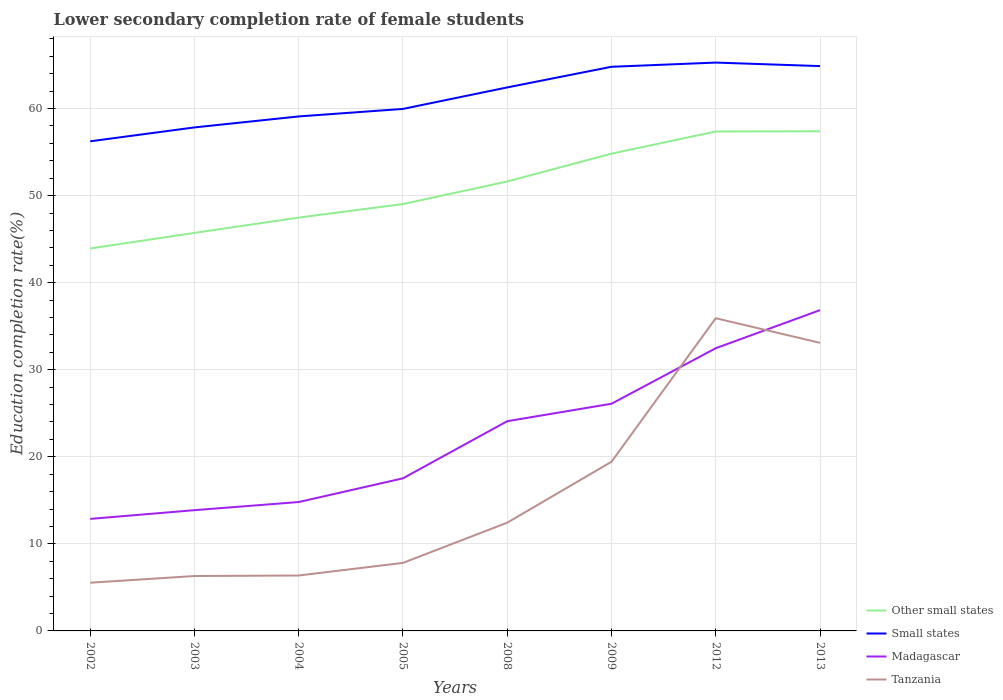Is the number of lines equal to the number of legend labels?
Offer a very short reply. Yes. Across all years, what is the maximum lower secondary completion rate of female students in Madagascar?
Your answer should be compact. 12.87. In which year was the lower secondary completion rate of female students in Madagascar maximum?
Your answer should be compact. 2002. What is the total lower secondary completion rate of female students in Other small states in the graph?
Your response must be concise. -5.9. What is the difference between the highest and the second highest lower secondary completion rate of female students in Madagascar?
Offer a very short reply. 23.98. Does the graph contain grids?
Offer a terse response. Yes. Where does the legend appear in the graph?
Make the answer very short. Bottom right. How many legend labels are there?
Offer a very short reply. 4. What is the title of the graph?
Provide a succinct answer. Lower secondary completion rate of female students. Does "Spain" appear as one of the legend labels in the graph?
Keep it short and to the point. No. What is the label or title of the Y-axis?
Your response must be concise. Education completion rate(%). What is the Education completion rate(%) of Other small states in 2002?
Make the answer very short. 43.92. What is the Education completion rate(%) of Small states in 2002?
Provide a short and direct response. 56.24. What is the Education completion rate(%) of Madagascar in 2002?
Make the answer very short. 12.87. What is the Education completion rate(%) in Tanzania in 2002?
Offer a terse response. 5.54. What is the Education completion rate(%) of Other small states in 2003?
Keep it short and to the point. 45.72. What is the Education completion rate(%) of Small states in 2003?
Your response must be concise. 57.83. What is the Education completion rate(%) in Madagascar in 2003?
Your answer should be very brief. 13.87. What is the Education completion rate(%) of Tanzania in 2003?
Give a very brief answer. 6.31. What is the Education completion rate(%) of Other small states in 2004?
Keep it short and to the point. 47.47. What is the Education completion rate(%) of Small states in 2004?
Keep it short and to the point. 59.09. What is the Education completion rate(%) in Madagascar in 2004?
Your answer should be compact. 14.8. What is the Education completion rate(%) in Tanzania in 2004?
Keep it short and to the point. 6.37. What is the Education completion rate(%) in Other small states in 2005?
Provide a short and direct response. 49.03. What is the Education completion rate(%) of Small states in 2005?
Offer a very short reply. 59.96. What is the Education completion rate(%) in Madagascar in 2005?
Provide a short and direct response. 17.53. What is the Education completion rate(%) in Tanzania in 2005?
Offer a terse response. 7.81. What is the Education completion rate(%) in Other small states in 2008?
Ensure brevity in your answer.  51.62. What is the Education completion rate(%) of Small states in 2008?
Your answer should be very brief. 62.43. What is the Education completion rate(%) in Madagascar in 2008?
Your answer should be compact. 24.09. What is the Education completion rate(%) of Tanzania in 2008?
Give a very brief answer. 12.43. What is the Education completion rate(%) of Other small states in 2009?
Ensure brevity in your answer.  54.82. What is the Education completion rate(%) in Small states in 2009?
Your answer should be very brief. 64.8. What is the Education completion rate(%) of Madagascar in 2009?
Keep it short and to the point. 26.09. What is the Education completion rate(%) of Tanzania in 2009?
Ensure brevity in your answer.  19.43. What is the Education completion rate(%) of Other small states in 2012?
Give a very brief answer. 57.36. What is the Education completion rate(%) of Small states in 2012?
Keep it short and to the point. 65.28. What is the Education completion rate(%) in Madagascar in 2012?
Make the answer very short. 32.47. What is the Education completion rate(%) of Tanzania in 2012?
Offer a very short reply. 35.92. What is the Education completion rate(%) of Other small states in 2013?
Offer a terse response. 57.39. What is the Education completion rate(%) in Small states in 2013?
Offer a very short reply. 64.87. What is the Education completion rate(%) in Madagascar in 2013?
Keep it short and to the point. 36.84. What is the Education completion rate(%) in Tanzania in 2013?
Give a very brief answer. 33.09. Across all years, what is the maximum Education completion rate(%) of Other small states?
Keep it short and to the point. 57.39. Across all years, what is the maximum Education completion rate(%) in Small states?
Provide a succinct answer. 65.28. Across all years, what is the maximum Education completion rate(%) in Madagascar?
Give a very brief answer. 36.84. Across all years, what is the maximum Education completion rate(%) in Tanzania?
Your response must be concise. 35.92. Across all years, what is the minimum Education completion rate(%) in Other small states?
Your answer should be very brief. 43.92. Across all years, what is the minimum Education completion rate(%) of Small states?
Provide a succinct answer. 56.24. Across all years, what is the minimum Education completion rate(%) of Madagascar?
Your answer should be very brief. 12.87. Across all years, what is the minimum Education completion rate(%) in Tanzania?
Keep it short and to the point. 5.54. What is the total Education completion rate(%) of Other small states in the graph?
Give a very brief answer. 407.34. What is the total Education completion rate(%) in Small states in the graph?
Your answer should be compact. 490.49. What is the total Education completion rate(%) of Madagascar in the graph?
Offer a terse response. 178.56. What is the total Education completion rate(%) of Tanzania in the graph?
Your response must be concise. 126.89. What is the difference between the Education completion rate(%) of Other small states in 2002 and that in 2003?
Give a very brief answer. -1.79. What is the difference between the Education completion rate(%) of Small states in 2002 and that in 2003?
Ensure brevity in your answer.  -1.6. What is the difference between the Education completion rate(%) of Madagascar in 2002 and that in 2003?
Your response must be concise. -1. What is the difference between the Education completion rate(%) in Tanzania in 2002 and that in 2003?
Offer a terse response. -0.77. What is the difference between the Education completion rate(%) of Other small states in 2002 and that in 2004?
Your response must be concise. -3.55. What is the difference between the Education completion rate(%) of Small states in 2002 and that in 2004?
Keep it short and to the point. -2.86. What is the difference between the Education completion rate(%) in Madagascar in 2002 and that in 2004?
Your answer should be compact. -1.94. What is the difference between the Education completion rate(%) in Tanzania in 2002 and that in 2004?
Provide a short and direct response. -0.83. What is the difference between the Education completion rate(%) in Other small states in 2002 and that in 2005?
Offer a very short reply. -5.11. What is the difference between the Education completion rate(%) of Small states in 2002 and that in 2005?
Your answer should be compact. -3.72. What is the difference between the Education completion rate(%) of Madagascar in 2002 and that in 2005?
Your answer should be compact. -4.66. What is the difference between the Education completion rate(%) in Tanzania in 2002 and that in 2005?
Provide a short and direct response. -2.28. What is the difference between the Education completion rate(%) of Other small states in 2002 and that in 2008?
Provide a short and direct response. -7.7. What is the difference between the Education completion rate(%) in Small states in 2002 and that in 2008?
Your answer should be compact. -6.19. What is the difference between the Education completion rate(%) in Madagascar in 2002 and that in 2008?
Make the answer very short. -11.22. What is the difference between the Education completion rate(%) in Tanzania in 2002 and that in 2008?
Ensure brevity in your answer.  -6.9. What is the difference between the Education completion rate(%) of Other small states in 2002 and that in 2009?
Offer a terse response. -10.89. What is the difference between the Education completion rate(%) of Small states in 2002 and that in 2009?
Offer a terse response. -8.56. What is the difference between the Education completion rate(%) in Madagascar in 2002 and that in 2009?
Offer a terse response. -13.23. What is the difference between the Education completion rate(%) of Tanzania in 2002 and that in 2009?
Make the answer very short. -13.89. What is the difference between the Education completion rate(%) in Other small states in 2002 and that in 2012?
Offer a very short reply. -13.44. What is the difference between the Education completion rate(%) in Small states in 2002 and that in 2012?
Offer a terse response. -9.04. What is the difference between the Education completion rate(%) in Madagascar in 2002 and that in 2012?
Provide a short and direct response. -19.6. What is the difference between the Education completion rate(%) of Tanzania in 2002 and that in 2012?
Keep it short and to the point. -30.38. What is the difference between the Education completion rate(%) in Other small states in 2002 and that in 2013?
Keep it short and to the point. -13.46. What is the difference between the Education completion rate(%) in Small states in 2002 and that in 2013?
Ensure brevity in your answer.  -8.64. What is the difference between the Education completion rate(%) in Madagascar in 2002 and that in 2013?
Offer a terse response. -23.98. What is the difference between the Education completion rate(%) in Tanzania in 2002 and that in 2013?
Provide a succinct answer. -27.55. What is the difference between the Education completion rate(%) in Other small states in 2003 and that in 2004?
Your response must be concise. -1.76. What is the difference between the Education completion rate(%) in Small states in 2003 and that in 2004?
Provide a succinct answer. -1.26. What is the difference between the Education completion rate(%) in Madagascar in 2003 and that in 2004?
Ensure brevity in your answer.  -0.93. What is the difference between the Education completion rate(%) in Tanzania in 2003 and that in 2004?
Make the answer very short. -0.06. What is the difference between the Education completion rate(%) in Other small states in 2003 and that in 2005?
Your answer should be compact. -3.31. What is the difference between the Education completion rate(%) in Small states in 2003 and that in 2005?
Provide a succinct answer. -2.12. What is the difference between the Education completion rate(%) of Madagascar in 2003 and that in 2005?
Provide a succinct answer. -3.66. What is the difference between the Education completion rate(%) of Tanzania in 2003 and that in 2005?
Provide a short and direct response. -1.51. What is the difference between the Education completion rate(%) of Other small states in 2003 and that in 2008?
Offer a terse response. -5.9. What is the difference between the Education completion rate(%) of Small states in 2003 and that in 2008?
Offer a terse response. -4.59. What is the difference between the Education completion rate(%) in Madagascar in 2003 and that in 2008?
Give a very brief answer. -10.22. What is the difference between the Education completion rate(%) in Tanzania in 2003 and that in 2008?
Offer a very short reply. -6.13. What is the difference between the Education completion rate(%) of Other small states in 2003 and that in 2009?
Your answer should be very brief. -9.1. What is the difference between the Education completion rate(%) of Small states in 2003 and that in 2009?
Offer a very short reply. -6.97. What is the difference between the Education completion rate(%) in Madagascar in 2003 and that in 2009?
Provide a short and direct response. -12.22. What is the difference between the Education completion rate(%) of Tanzania in 2003 and that in 2009?
Give a very brief answer. -13.12. What is the difference between the Education completion rate(%) in Other small states in 2003 and that in 2012?
Provide a succinct answer. -11.65. What is the difference between the Education completion rate(%) of Small states in 2003 and that in 2012?
Your answer should be very brief. -7.45. What is the difference between the Education completion rate(%) of Madagascar in 2003 and that in 2012?
Offer a terse response. -18.6. What is the difference between the Education completion rate(%) of Tanzania in 2003 and that in 2012?
Keep it short and to the point. -29.61. What is the difference between the Education completion rate(%) in Other small states in 2003 and that in 2013?
Your response must be concise. -11.67. What is the difference between the Education completion rate(%) in Small states in 2003 and that in 2013?
Provide a succinct answer. -7.04. What is the difference between the Education completion rate(%) in Madagascar in 2003 and that in 2013?
Provide a succinct answer. -22.97. What is the difference between the Education completion rate(%) in Tanzania in 2003 and that in 2013?
Offer a very short reply. -26.78. What is the difference between the Education completion rate(%) in Other small states in 2004 and that in 2005?
Provide a short and direct response. -1.56. What is the difference between the Education completion rate(%) of Small states in 2004 and that in 2005?
Provide a short and direct response. -0.86. What is the difference between the Education completion rate(%) in Madagascar in 2004 and that in 2005?
Your response must be concise. -2.72. What is the difference between the Education completion rate(%) in Tanzania in 2004 and that in 2005?
Give a very brief answer. -1.45. What is the difference between the Education completion rate(%) in Other small states in 2004 and that in 2008?
Your response must be concise. -4.15. What is the difference between the Education completion rate(%) in Small states in 2004 and that in 2008?
Your answer should be very brief. -3.33. What is the difference between the Education completion rate(%) of Madagascar in 2004 and that in 2008?
Keep it short and to the point. -9.29. What is the difference between the Education completion rate(%) in Tanzania in 2004 and that in 2008?
Make the answer very short. -6.07. What is the difference between the Education completion rate(%) in Other small states in 2004 and that in 2009?
Offer a very short reply. -7.34. What is the difference between the Education completion rate(%) in Small states in 2004 and that in 2009?
Keep it short and to the point. -5.7. What is the difference between the Education completion rate(%) of Madagascar in 2004 and that in 2009?
Provide a succinct answer. -11.29. What is the difference between the Education completion rate(%) in Tanzania in 2004 and that in 2009?
Keep it short and to the point. -13.06. What is the difference between the Education completion rate(%) in Other small states in 2004 and that in 2012?
Your response must be concise. -9.89. What is the difference between the Education completion rate(%) in Small states in 2004 and that in 2012?
Offer a terse response. -6.18. What is the difference between the Education completion rate(%) of Madagascar in 2004 and that in 2012?
Provide a succinct answer. -17.67. What is the difference between the Education completion rate(%) of Tanzania in 2004 and that in 2012?
Your response must be concise. -29.55. What is the difference between the Education completion rate(%) in Other small states in 2004 and that in 2013?
Offer a terse response. -9.91. What is the difference between the Education completion rate(%) in Small states in 2004 and that in 2013?
Keep it short and to the point. -5.78. What is the difference between the Education completion rate(%) in Madagascar in 2004 and that in 2013?
Provide a short and direct response. -22.04. What is the difference between the Education completion rate(%) of Tanzania in 2004 and that in 2013?
Offer a very short reply. -26.72. What is the difference between the Education completion rate(%) in Other small states in 2005 and that in 2008?
Offer a very short reply. -2.59. What is the difference between the Education completion rate(%) in Small states in 2005 and that in 2008?
Give a very brief answer. -2.47. What is the difference between the Education completion rate(%) in Madagascar in 2005 and that in 2008?
Give a very brief answer. -6.56. What is the difference between the Education completion rate(%) of Tanzania in 2005 and that in 2008?
Provide a short and direct response. -4.62. What is the difference between the Education completion rate(%) in Other small states in 2005 and that in 2009?
Your answer should be compact. -5.79. What is the difference between the Education completion rate(%) in Small states in 2005 and that in 2009?
Your answer should be very brief. -4.84. What is the difference between the Education completion rate(%) of Madagascar in 2005 and that in 2009?
Your answer should be compact. -8.57. What is the difference between the Education completion rate(%) of Tanzania in 2005 and that in 2009?
Your response must be concise. -11.61. What is the difference between the Education completion rate(%) of Other small states in 2005 and that in 2012?
Make the answer very short. -8.33. What is the difference between the Education completion rate(%) in Small states in 2005 and that in 2012?
Ensure brevity in your answer.  -5.32. What is the difference between the Education completion rate(%) in Madagascar in 2005 and that in 2012?
Your answer should be very brief. -14.94. What is the difference between the Education completion rate(%) of Tanzania in 2005 and that in 2012?
Provide a succinct answer. -28.1. What is the difference between the Education completion rate(%) in Other small states in 2005 and that in 2013?
Give a very brief answer. -8.36. What is the difference between the Education completion rate(%) in Small states in 2005 and that in 2013?
Offer a very short reply. -4.92. What is the difference between the Education completion rate(%) of Madagascar in 2005 and that in 2013?
Provide a short and direct response. -19.32. What is the difference between the Education completion rate(%) in Tanzania in 2005 and that in 2013?
Your answer should be very brief. -25.27. What is the difference between the Education completion rate(%) of Other small states in 2008 and that in 2009?
Provide a succinct answer. -3.2. What is the difference between the Education completion rate(%) in Small states in 2008 and that in 2009?
Offer a very short reply. -2.37. What is the difference between the Education completion rate(%) in Madagascar in 2008 and that in 2009?
Your answer should be compact. -2.01. What is the difference between the Education completion rate(%) of Tanzania in 2008 and that in 2009?
Your answer should be very brief. -7. What is the difference between the Education completion rate(%) in Other small states in 2008 and that in 2012?
Give a very brief answer. -5.74. What is the difference between the Education completion rate(%) in Small states in 2008 and that in 2012?
Your response must be concise. -2.85. What is the difference between the Education completion rate(%) of Madagascar in 2008 and that in 2012?
Provide a succinct answer. -8.38. What is the difference between the Education completion rate(%) in Tanzania in 2008 and that in 2012?
Keep it short and to the point. -23.48. What is the difference between the Education completion rate(%) in Other small states in 2008 and that in 2013?
Offer a terse response. -5.77. What is the difference between the Education completion rate(%) in Small states in 2008 and that in 2013?
Provide a short and direct response. -2.45. What is the difference between the Education completion rate(%) in Madagascar in 2008 and that in 2013?
Your answer should be very brief. -12.75. What is the difference between the Education completion rate(%) of Tanzania in 2008 and that in 2013?
Keep it short and to the point. -20.66. What is the difference between the Education completion rate(%) in Other small states in 2009 and that in 2012?
Make the answer very short. -2.55. What is the difference between the Education completion rate(%) of Small states in 2009 and that in 2012?
Give a very brief answer. -0.48. What is the difference between the Education completion rate(%) of Madagascar in 2009 and that in 2012?
Ensure brevity in your answer.  -6.38. What is the difference between the Education completion rate(%) of Tanzania in 2009 and that in 2012?
Ensure brevity in your answer.  -16.49. What is the difference between the Education completion rate(%) in Other small states in 2009 and that in 2013?
Your answer should be compact. -2.57. What is the difference between the Education completion rate(%) in Small states in 2009 and that in 2013?
Offer a very short reply. -0.08. What is the difference between the Education completion rate(%) of Madagascar in 2009 and that in 2013?
Your response must be concise. -10.75. What is the difference between the Education completion rate(%) of Tanzania in 2009 and that in 2013?
Your answer should be very brief. -13.66. What is the difference between the Education completion rate(%) of Other small states in 2012 and that in 2013?
Provide a succinct answer. -0.02. What is the difference between the Education completion rate(%) in Small states in 2012 and that in 2013?
Offer a very short reply. 0.4. What is the difference between the Education completion rate(%) in Madagascar in 2012 and that in 2013?
Offer a very short reply. -4.37. What is the difference between the Education completion rate(%) in Tanzania in 2012 and that in 2013?
Your answer should be compact. 2.83. What is the difference between the Education completion rate(%) in Other small states in 2002 and the Education completion rate(%) in Small states in 2003?
Offer a very short reply. -13.91. What is the difference between the Education completion rate(%) of Other small states in 2002 and the Education completion rate(%) of Madagascar in 2003?
Your answer should be very brief. 30.05. What is the difference between the Education completion rate(%) in Other small states in 2002 and the Education completion rate(%) in Tanzania in 2003?
Keep it short and to the point. 37.62. What is the difference between the Education completion rate(%) of Small states in 2002 and the Education completion rate(%) of Madagascar in 2003?
Your response must be concise. 42.37. What is the difference between the Education completion rate(%) in Small states in 2002 and the Education completion rate(%) in Tanzania in 2003?
Keep it short and to the point. 49.93. What is the difference between the Education completion rate(%) of Madagascar in 2002 and the Education completion rate(%) of Tanzania in 2003?
Make the answer very short. 6.56. What is the difference between the Education completion rate(%) of Other small states in 2002 and the Education completion rate(%) of Small states in 2004?
Make the answer very short. -15.17. What is the difference between the Education completion rate(%) in Other small states in 2002 and the Education completion rate(%) in Madagascar in 2004?
Your answer should be compact. 29.12. What is the difference between the Education completion rate(%) in Other small states in 2002 and the Education completion rate(%) in Tanzania in 2004?
Provide a short and direct response. 37.56. What is the difference between the Education completion rate(%) of Small states in 2002 and the Education completion rate(%) of Madagascar in 2004?
Your answer should be compact. 41.43. What is the difference between the Education completion rate(%) in Small states in 2002 and the Education completion rate(%) in Tanzania in 2004?
Your answer should be very brief. 49.87. What is the difference between the Education completion rate(%) of Madagascar in 2002 and the Education completion rate(%) of Tanzania in 2004?
Your answer should be compact. 6.5. What is the difference between the Education completion rate(%) of Other small states in 2002 and the Education completion rate(%) of Small states in 2005?
Give a very brief answer. -16.03. What is the difference between the Education completion rate(%) of Other small states in 2002 and the Education completion rate(%) of Madagascar in 2005?
Offer a very short reply. 26.4. What is the difference between the Education completion rate(%) of Other small states in 2002 and the Education completion rate(%) of Tanzania in 2005?
Offer a terse response. 36.11. What is the difference between the Education completion rate(%) in Small states in 2002 and the Education completion rate(%) in Madagascar in 2005?
Your answer should be compact. 38.71. What is the difference between the Education completion rate(%) in Small states in 2002 and the Education completion rate(%) in Tanzania in 2005?
Provide a succinct answer. 48.42. What is the difference between the Education completion rate(%) in Madagascar in 2002 and the Education completion rate(%) in Tanzania in 2005?
Keep it short and to the point. 5.05. What is the difference between the Education completion rate(%) of Other small states in 2002 and the Education completion rate(%) of Small states in 2008?
Give a very brief answer. -18.5. What is the difference between the Education completion rate(%) of Other small states in 2002 and the Education completion rate(%) of Madagascar in 2008?
Offer a very short reply. 19.84. What is the difference between the Education completion rate(%) in Other small states in 2002 and the Education completion rate(%) in Tanzania in 2008?
Offer a terse response. 31.49. What is the difference between the Education completion rate(%) in Small states in 2002 and the Education completion rate(%) in Madagascar in 2008?
Your answer should be very brief. 32.15. What is the difference between the Education completion rate(%) in Small states in 2002 and the Education completion rate(%) in Tanzania in 2008?
Make the answer very short. 43.8. What is the difference between the Education completion rate(%) of Madagascar in 2002 and the Education completion rate(%) of Tanzania in 2008?
Keep it short and to the point. 0.43. What is the difference between the Education completion rate(%) of Other small states in 2002 and the Education completion rate(%) of Small states in 2009?
Your answer should be very brief. -20.87. What is the difference between the Education completion rate(%) in Other small states in 2002 and the Education completion rate(%) in Madagascar in 2009?
Keep it short and to the point. 17.83. What is the difference between the Education completion rate(%) of Other small states in 2002 and the Education completion rate(%) of Tanzania in 2009?
Offer a very short reply. 24.5. What is the difference between the Education completion rate(%) in Small states in 2002 and the Education completion rate(%) in Madagascar in 2009?
Your answer should be compact. 30.14. What is the difference between the Education completion rate(%) in Small states in 2002 and the Education completion rate(%) in Tanzania in 2009?
Your answer should be compact. 36.81. What is the difference between the Education completion rate(%) in Madagascar in 2002 and the Education completion rate(%) in Tanzania in 2009?
Your response must be concise. -6.56. What is the difference between the Education completion rate(%) of Other small states in 2002 and the Education completion rate(%) of Small states in 2012?
Provide a succinct answer. -21.35. What is the difference between the Education completion rate(%) in Other small states in 2002 and the Education completion rate(%) in Madagascar in 2012?
Offer a very short reply. 11.45. What is the difference between the Education completion rate(%) of Other small states in 2002 and the Education completion rate(%) of Tanzania in 2012?
Provide a succinct answer. 8.01. What is the difference between the Education completion rate(%) of Small states in 2002 and the Education completion rate(%) of Madagascar in 2012?
Give a very brief answer. 23.77. What is the difference between the Education completion rate(%) in Small states in 2002 and the Education completion rate(%) in Tanzania in 2012?
Offer a terse response. 20.32. What is the difference between the Education completion rate(%) in Madagascar in 2002 and the Education completion rate(%) in Tanzania in 2012?
Keep it short and to the point. -23.05. What is the difference between the Education completion rate(%) in Other small states in 2002 and the Education completion rate(%) in Small states in 2013?
Your response must be concise. -20.95. What is the difference between the Education completion rate(%) in Other small states in 2002 and the Education completion rate(%) in Madagascar in 2013?
Offer a terse response. 7.08. What is the difference between the Education completion rate(%) of Other small states in 2002 and the Education completion rate(%) of Tanzania in 2013?
Your answer should be compact. 10.83. What is the difference between the Education completion rate(%) of Small states in 2002 and the Education completion rate(%) of Madagascar in 2013?
Your answer should be compact. 19.39. What is the difference between the Education completion rate(%) in Small states in 2002 and the Education completion rate(%) in Tanzania in 2013?
Ensure brevity in your answer.  23.15. What is the difference between the Education completion rate(%) in Madagascar in 2002 and the Education completion rate(%) in Tanzania in 2013?
Your answer should be compact. -20.22. What is the difference between the Education completion rate(%) of Other small states in 2003 and the Education completion rate(%) of Small states in 2004?
Your response must be concise. -13.38. What is the difference between the Education completion rate(%) of Other small states in 2003 and the Education completion rate(%) of Madagascar in 2004?
Your answer should be very brief. 30.92. What is the difference between the Education completion rate(%) in Other small states in 2003 and the Education completion rate(%) in Tanzania in 2004?
Offer a terse response. 39.35. What is the difference between the Education completion rate(%) in Small states in 2003 and the Education completion rate(%) in Madagascar in 2004?
Your answer should be very brief. 43.03. What is the difference between the Education completion rate(%) in Small states in 2003 and the Education completion rate(%) in Tanzania in 2004?
Provide a succinct answer. 51.47. What is the difference between the Education completion rate(%) in Madagascar in 2003 and the Education completion rate(%) in Tanzania in 2004?
Ensure brevity in your answer.  7.5. What is the difference between the Education completion rate(%) in Other small states in 2003 and the Education completion rate(%) in Small states in 2005?
Give a very brief answer. -14.24. What is the difference between the Education completion rate(%) in Other small states in 2003 and the Education completion rate(%) in Madagascar in 2005?
Your answer should be compact. 28.19. What is the difference between the Education completion rate(%) in Other small states in 2003 and the Education completion rate(%) in Tanzania in 2005?
Your answer should be compact. 37.9. What is the difference between the Education completion rate(%) in Small states in 2003 and the Education completion rate(%) in Madagascar in 2005?
Provide a succinct answer. 40.31. What is the difference between the Education completion rate(%) in Small states in 2003 and the Education completion rate(%) in Tanzania in 2005?
Your answer should be very brief. 50.02. What is the difference between the Education completion rate(%) in Madagascar in 2003 and the Education completion rate(%) in Tanzania in 2005?
Make the answer very short. 6.06. What is the difference between the Education completion rate(%) in Other small states in 2003 and the Education completion rate(%) in Small states in 2008?
Offer a very short reply. -16.71. What is the difference between the Education completion rate(%) of Other small states in 2003 and the Education completion rate(%) of Madagascar in 2008?
Keep it short and to the point. 21.63. What is the difference between the Education completion rate(%) in Other small states in 2003 and the Education completion rate(%) in Tanzania in 2008?
Offer a terse response. 33.29. What is the difference between the Education completion rate(%) in Small states in 2003 and the Education completion rate(%) in Madagascar in 2008?
Give a very brief answer. 33.74. What is the difference between the Education completion rate(%) of Small states in 2003 and the Education completion rate(%) of Tanzania in 2008?
Your answer should be very brief. 45.4. What is the difference between the Education completion rate(%) in Madagascar in 2003 and the Education completion rate(%) in Tanzania in 2008?
Your answer should be compact. 1.44. What is the difference between the Education completion rate(%) of Other small states in 2003 and the Education completion rate(%) of Small states in 2009?
Your answer should be very brief. -19.08. What is the difference between the Education completion rate(%) in Other small states in 2003 and the Education completion rate(%) in Madagascar in 2009?
Your response must be concise. 19.62. What is the difference between the Education completion rate(%) in Other small states in 2003 and the Education completion rate(%) in Tanzania in 2009?
Your response must be concise. 26.29. What is the difference between the Education completion rate(%) of Small states in 2003 and the Education completion rate(%) of Madagascar in 2009?
Provide a short and direct response. 31.74. What is the difference between the Education completion rate(%) in Small states in 2003 and the Education completion rate(%) in Tanzania in 2009?
Provide a short and direct response. 38.4. What is the difference between the Education completion rate(%) in Madagascar in 2003 and the Education completion rate(%) in Tanzania in 2009?
Provide a short and direct response. -5.56. What is the difference between the Education completion rate(%) in Other small states in 2003 and the Education completion rate(%) in Small states in 2012?
Offer a terse response. -19.56. What is the difference between the Education completion rate(%) of Other small states in 2003 and the Education completion rate(%) of Madagascar in 2012?
Keep it short and to the point. 13.25. What is the difference between the Education completion rate(%) in Other small states in 2003 and the Education completion rate(%) in Tanzania in 2012?
Your answer should be compact. 9.8. What is the difference between the Education completion rate(%) in Small states in 2003 and the Education completion rate(%) in Madagascar in 2012?
Provide a succinct answer. 25.36. What is the difference between the Education completion rate(%) of Small states in 2003 and the Education completion rate(%) of Tanzania in 2012?
Ensure brevity in your answer.  21.92. What is the difference between the Education completion rate(%) in Madagascar in 2003 and the Education completion rate(%) in Tanzania in 2012?
Offer a terse response. -22.05. What is the difference between the Education completion rate(%) in Other small states in 2003 and the Education completion rate(%) in Small states in 2013?
Your answer should be very brief. -19.16. What is the difference between the Education completion rate(%) in Other small states in 2003 and the Education completion rate(%) in Madagascar in 2013?
Offer a terse response. 8.88. What is the difference between the Education completion rate(%) of Other small states in 2003 and the Education completion rate(%) of Tanzania in 2013?
Your answer should be very brief. 12.63. What is the difference between the Education completion rate(%) in Small states in 2003 and the Education completion rate(%) in Madagascar in 2013?
Give a very brief answer. 20.99. What is the difference between the Education completion rate(%) of Small states in 2003 and the Education completion rate(%) of Tanzania in 2013?
Offer a very short reply. 24.74. What is the difference between the Education completion rate(%) of Madagascar in 2003 and the Education completion rate(%) of Tanzania in 2013?
Keep it short and to the point. -19.22. What is the difference between the Education completion rate(%) of Other small states in 2004 and the Education completion rate(%) of Small states in 2005?
Your answer should be compact. -12.48. What is the difference between the Education completion rate(%) in Other small states in 2004 and the Education completion rate(%) in Madagascar in 2005?
Keep it short and to the point. 29.95. What is the difference between the Education completion rate(%) in Other small states in 2004 and the Education completion rate(%) in Tanzania in 2005?
Offer a very short reply. 39.66. What is the difference between the Education completion rate(%) of Small states in 2004 and the Education completion rate(%) of Madagascar in 2005?
Your answer should be very brief. 41.57. What is the difference between the Education completion rate(%) of Small states in 2004 and the Education completion rate(%) of Tanzania in 2005?
Provide a succinct answer. 51.28. What is the difference between the Education completion rate(%) in Madagascar in 2004 and the Education completion rate(%) in Tanzania in 2005?
Provide a succinct answer. 6.99. What is the difference between the Education completion rate(%) of Other small states in 2004 and the Education completion rate(%) of Small states in 2008?
Offer a very short reply. -14.95. What is the difference between the Education completion rate(%) of Other small states in 2004 and the Education completion rate(%) of Madagascar in 2008?
Ensure brevity in your answer.  23.39. What is the difference between the Education completion rate(%) in Other small states in 2004 and the Education completion rate(%) in Tanzania in 2008?
Make the answer very short. 35.04. What is the difference between the Education completion rate(%) of Small states in 2004 and the Education completion rate(%) of Madagascar in 2008?
Your answer should be compact. 35.01. What is the difference between the Education completion rate(%) of Small states in 2004 and the Education completion rate(%) of Tanzania in 2008?
Provide a succinct answer. 46.66. What is the difference between the Education completion rate(%) of Madagascar in 2004 and the Education completion rate(%) of Tanzania in 2008?
Make the answer very short. 2.37. What is the difference between the Education completion rate(%) in Other small states in 2004 and the Education completion rate(%) in Small states in 2009?
Give a very brief answer. -17.32. What is the difference between the Education completion rate(%) in Other small states in 2004 and the Education completion rate(%) in Madagascar in 2009?
Your response must be concise. 21.38. What is the difference between the Education completion rate(%) of Other small states in 2004 and the Education completion rate(%) of Tanzania in 2009?
Offer a terse response. 28.05. What is the difference between the Education completion rate(%) in Small states in 2004 and the Education completion rate(%) in Madagascar in 2009?
Your answer should be very brief. 33. What is the difference between the Education completion rate(%) in Small states in 2004 and the Education completion rate(%) in Tanzania in 2009?
Keep it short and to the point. 39.67. What is the difference between the Education completion rate(%) of Madagascar in 2004 and the Education completion rate(%) of Tanzania in 2009?
Provide a succinct answer. -4.62. What is the difference between the Education completion rate(%) of Other small states in 2004 and the Education completion rate(%) of Small states in 2012?
Your response must be concise. -17.8. What is the difference between the Education completion rate(%) of Other small states in 2004 and the Education completion rate(%) of Madagascar in 2012?
Provide a short and direct response. 15. What is the difference between the Education completion rate(%) of Other small states in 2004 and the Education completion rate(%) of Tanzania in 2012?
Provide a short and direct response. 11.56. What is the difference between the Education completion rate(%) in Small states in 2004 and the Education completion rate(%) in Madagascar in 2012?
Your answer should be very brief. 26.62. What is the difference between the Education completion rate(%) in Small states in 2004 and the Education completion rate(%) in Tanzania in 2012?
Give a very brief answer. 23.18. What is the difference between the Education completion rate(%) in Madagascar in 2004 and the Education completion rate(%) in Tanzania in 2012?
Make the answer very short. -21.11. What is the difference between the Education completion rate(%) in Other small states in 2004 and the Education completion rate(%) in Small states in 2013?
Give a very brief answer. -17.4. What is the difference between the Education completion rate(%) of Other small states in 2004 and the Education completion rate(%) of Madagascar in 2013?
Your answer should be compact. 10.63. What is the difference between the Education completion rate(%) in Other small states in 2004 and the Education completion rate(%) in Tanzania in 2013?
Provide a succinct answer. 14.38. What is the difference between the Education completion rate(%) in Small states in 2004 and the Education completion rate(%) in Madagascar in 2013?
Provide a succinct answer. 22.25. What is the difference between the Education completion rate(%) of Small states in 2004 and the Education completion rate(%) of Tanzania in 2013?
Provide a short and direct response. 26. What is the difference between the Education completion rate(%) in Madagascar in 2004 and the Education completion rate(%) in Tanzania in 2013?
Keep it short and to the point. -18.29. What is the difference between the Education completion rate(%) in Other small states in 2005 and the Education completion rate(%) in Small states in 2008?
Make the answer very short. -13.4. What is the difference between the Education completion rate(%) in Other small states in 2005 and the Education completion rate(%) in Madagascar in 2008?
Keep it short and to the point. 24.94. What is the difference between the Education completion rate(%) of Other small states in 2005 and the Education completion rate(%) of Tanzania in 2008?
Ensure brevity in your answer.  36.6. What is the difference between the Education completion rate(%) of Small states in 2005 and the Education completion rate(%) of Madagascar in 2008?
Your answer should be compact. 35.87. What is the difference between the Education completion rate(%) in Small states in 2005 and the Education completion rate(%) in Tanzania in 2008?
Offer a very short reply. 47.52. What is the difference between the Education completion rate(%) of Madagascar in 2005 and the Education completion rate(%) of Tanzania in 2008?
Offer a terse response. 5.09. What is the difference between the Education completion rate(%) of Other small states in 2005 and the Education completion rate(%) of Small states in 2009?
Your answer should be very brief. -15.77. What is the difference between the Education completion rate(%) of Other small states in 2005 and the Education completion rate(%) of Madagascar in 2009?
Make the answer very short. 22.94. What is the difference between the Education completion rate(%) in Other small states in 2005 and the Education completion rate(%) in Tanzania in 2009?
Provide a short and direct response. 29.6. What is the difference between the Education completion rate(%) of Small states in 2005 and the Education completion rate(%) of Madagascar in 2009?
Keep it short and to the point. 33.86. What is the difference between the Education completion rate(%) in Small states in 2005 and the Education completion rate(%) in Tanzania in 2009?
Make the answer very short. 40.53. What is the difference between the Education completion rate(%) of Madagascar in 2005 and the Education completion rate(%) of Tanzania in 2009?
Your response must be concise. -1.9. What is the difference between the Education completion rate(%) of Other small states in 2005 and the Education completion rate(%) of Small states in 2012?
Ensure brevity in your answer.  -16.25. What is the difference between the Education completion rate(%) in Other small states in 2005 and the Education completion rate(%) in Madagascar in 2012?
Ensure brevity in your answer.  16.56. What is the difference between the Education completion rate(%) of Other small states in 2005 and the Education completion rate(%) of Tanzania in 2012?
Offer a very short reply. 13.12. What is the difference between the Education completion rate(%) in Small states in 2005 and the Education completion rate(%) in Madagascar in 2012?
Ensure brevity in your answer.  27.49. What is the difference between the Education completion rate(%) of Small states in 2005 and the Education completion rate(%) of Tanzania in 2012?
Offer a very short reply. 24.04. What is the difference between the Education completion rate(%) of Madagascar in 2005 and the Education completion rate(%) of Tanzania in 2012?
Provide a succinct answer. -18.39. What is the difference between the Education completion rate(%) in Other small states in 2005 and the Education completion rate(%) in Small states in 2013?
Your answer should be compact. -15.84. What is the difference between the Education completion rate(%) of Other small states in 2005 and the Education completion rate(%) of Madagascar in 2013?
Provide a succinct answer. 12.19. What is the difference between the Education completion rate(%) in Other small states in 2005 and the Education completion rate(%) in Tanzania in 2013?
Make the answer very short. 15.94. What is the difference between the Education completion rate(%) in Small states in 2005 and the Education completion rate(%) in Madagascar in 2013?
Your answer should be very brief. 23.11. What is the difference between the Education completion rate(%) in Small states in 2005 and the Education completion rate(%) in Tanzania in 2013?
Provide a short and direct response. 26.87. What is the difference between the Education completion rate(%) of Madagascar in 2005 and the Education completion rate(%) of Tanzania in 2013?
Ensure brevity in your answer.  -15.56. What is the difference between the Education completion rate(%) in Other small states in 2008 and the Education completion rate(%) in Small states in 2009?
Provide a succinct answer. -13.18. What is the difference between the Education completion rate(%) in Other small states in 2008 and the Education completion rate(%) in Madagascar in 2009?
Your response must be concise. 25.53. What is the difference between the Education completion rate(%) in Other small states in 2008 and the Education completion rate(%) in Tanzania in 2009?
Make the answer very short. 32.19. What is the difference between the Education completion rate(%) in Small states in 2008 and the Education completion rate(%) in Madagascar in 2009?
Keep it short and to the point. 36.33. What is the difference between the Education completion rate(%) of Small states in 2008 and the Education completion rate(%) of Tanzania in 2009?
Ensure brevity in your answer.  43. What is the difference between the Education completion rate(%) in Madagascar in 2008 and the Education completion rate(%) in Tanzania in 2009?
Make the answer very short. 4.66. What is the difference between the Education completion rate(%) of Other small states in 2008 and the Education completion rate(%) of Small states in 2012?
Give a very brief answer. -13.66. What is the difference between the Education completion rate(%) in Other small states in 2008 and the Education completion rate(%) in Madagascar in 2012?
Offer a terse response. 19.15. What is the difference between the Education completion rate(%) of Other small states in 2008 and the Education completion rate(%) of Tanzania in 2012?
Give a very brief answer. 15.71. What is the difference between the Education completion rate(%) of Small states in 2008 and the Education completion rate(%) of Madagascar in 2012?
Ensure brevity in your answer.  29.96. What is the difference between the Education completion rate(%) of Small states in 2008 and the Education completion rate(%) of Tanzania in 2012?
Your response must be concise. 26.51. What is the difference between the Education completion rate(%) in Madagascar in 2008 and the Education completion rate(%) in Tanzania in 2012?
Provide a short and direct response. -11.83. What is the difference between the Education completion rate(%) in Other small states in 2008 and the Education completion rate(%) in Small states in 2013?
Keep it short and to the point. -13.25. What is the difference between the Education completion rate(%) of Other small states in 2008 and the Education completion rate(%) of Madagascar in 2013?
Keep it short and to the point. 14.78. What is the difference between the Education completion rate(%) of Other small states in 2008 and the Education completion rate(%) of Tanzania in 2013?
Keep it short and to the point. 18.53. What is the difference between the Education completion rate(%) of Small states in 2008 and the Education completion rate(%) of Madagascar in 2013?
Provide a succinct answer. 25.58. What is the difference between the Education completion rate(%) of Small states in 2008 and the Education completion rate(%) of Tanzania in 2013?
Your response must be concise. 29.34. What is the difference between the Education completion rate(%) in Madagascar in 2008 and the Education completion rate(%) in Tanzania in 2013?
Your response must be concise. -9. What is the difference between the Education completion rate(%) of Other small states in 2009 and the Education completion rate(%) of Small states in 2012?
Give a very brief answer. -10.46. What is the difference between the Education completion rate(%) of Other small states in 2009 and the Education completion rate(%) of Madagascar in 2012?
Give a very brief answer. 22.35. What is the difference between the Education completion rate(%) in Other small states in 2009 and the Education completion rate(%) in Tanzania in 2012?
Your answer should be compact. 18.9. What is the difference between the Education completion rate(%) of Small states in 2009 and the Education completion rate(%) of Madagascar in 2012?
Your answer should be compact. 32.33. What is the difference between the Education completion rate(%) of Small states in 2009 and the Education completion rate(%) of Tanzania in 2012?
Ensure brevity in your answer.  28.88. What is the difference between the Education completion rate(%) in Madagascar in 2009 and the Education completion rate(%) in Tanzania in 2012?
Offer a very short reply. -9.82. What is the difference between the Education completion rate(%) in Other small states in 2009 and the Education completion rate(%) in Small states in 2013?
Give a very brief answer. -10.06. What is the difference between the Education completion rate(%) of Other small states in 2009 and the Education completion rate(%) of Madagascar in 2013?
Your answer should be very brief. 17.97. What is the difference between the Education completion rate(%) in Other small states in 2009 and the Education completion rate(%) in Tanzania in 2013?
Keep it short and to the point. 21.73. What is the difference between the Education completion rate(%) in Small states in 2009 and the Education completion rate(%) in Madagascar in 2013?
Your answer should be compact. 27.95. What is the difference between the Education completion rate(%) of Small states in 2009 and the Education completion rate(%) of Tanzania in 2013?
Provide a short and direct response. 31.71. What is the difference between the Education completion rate(%) of Madagascar in 2009 and the Education completion rate(%) of Tanzania in 2013?
Your answer should be compact. -7. What is the difference between the Education completion rate(%) in Other small states in 2012 and the Education completion rate(%) in Small states in 2013?
Give a very brief answer. -7.51. What is the difference between the Education completion rate(%) of Other small states in 2012 and the Education completion rate(%) of Madagascar in 2013?
Make the answer very short. 20.52. What is the difference between the Education completion rate(%) in Other small states in 2012 and the Education completion rate(%) in Tanzania in 2013?
Give a very brief answer. 24.27. What is the difference between the Education completion rate(%) in Small states in 2012 and the Education completion rate(%) in Madagascar in 2013?
Provide a short and direct response. 28.43. What is the difference between the Education completion rate(%) in Small states in 2012 and the Education completion rate(%) in Tanzania in 2013?
Your answer should be very brief. 32.19. What is the difference between the Education completion rate(%) in Madagascar in 2012 and the Education completion rate(%) in Tanzania in 2013?
Your answer should be compact. -0.62. What is the average Education completion rate(%) of Other small states per year?
Your response must be concise. 50.92. What is the average Education completion rate(%) of Small states per year?
Ensure brevity in your answer.  61.31. What is the average Education completion rate(%) of Madagascar per year?
Keep it short and to the point. 22.32. What is the average Education completion rate(%) of Tanzania per year?
Give a very brief answer. 15.86. In the year 2002, what is the difference between the Education completion rate(%) of Other small states and Education completion rate(%) of Small states?
Give a very brief answer. -12.31. In the year 2002, what is the difference between the Education completion rate(%) in Other small states and Education completion rate(%) in Madagascar?
Your response must be concise. 31.06. In the year 2002, what is the difference between the Education completion rate(%) in Other small states and Education completion rate(%) in Tanzania?
Give a very brief answer. 38.39. In the year 2002, what is the difference between the Education completion rate(%) of Small states and Education completion rate(%) of Madagascar?
Offer a very short reply. 43.37. In the year 2002, what is the difference between the Education completion rate(%) in Small states and Education completion rate(%) in Tanzania?
Offer a terse response. 50.7. In the year 2002, what is the difference between the Education completion rate(%) in Madagascar and Education completion rate(%) in Tanzania?
Ensure brevity in your answer.  7.33. In the year 2003, what is the difference between the Education completion rate(%) in Other small states and Education completion rate(%) in Small states?
Ensure brevity in your answer.  -12.11. In the year 2003, what is the difference between the Education completion rate(%) in Other small states and Education completion rate(%) in Madagascar?
Provide a short and direct response. 31.85. In the year 2003, what is the difference between the Education completion rate(%) of Other small states and Education completion rate(%) of Tanzania?
Your answer should be compact. 39.41. In the year 2003, what is the difference between the Education completion rate(%) of Small states and Education completion rate(%) of Madagascar?
Your answer should be compact. 43.96. In the year 2003, what is the difference between the Education completion rate(%) of Small states and Education completion rate(%) of Tanzania?
Keep it short and to the point. 51.53. In the year 2003, what is the difference between the Education completion rate(%) of Madagascar and Education completion rate(%) of Tanzania?
Offer a terse response. 7.56. In the year 2004, what is the difference between the Education completion rate(%) in Other small states and Education completion rate(%) in Small states?
Make the answer very short. -11.62. In the year 2004, what is the difference between the Education completion rate(%) of Other small states and Education completion rate(%) of Madagascar?
Your response must be concise. 32.67. In the year 2004, what is the difference between the Education completion rate(%) in Other small states and Education completion rate(%) in Tanzania?
Provide a short and direct response. 41.11. In the year 2004, what is the difference between the Education completion rate(%) in Small states and Education completion rate(%) in Madagascar?
Ensure brevity in your answer.  44.29. In the year 2004, what is the difference between the Education completion rate(%) in Small states and Education completion rate(%) in Tanzania?
Make the answer very short. 52.73. In the year 2004, what is the difference between the Education completion rate(%) in Madagascar and Education completion rate(%) in Tanzania?
Provide a short and direct response. 8.44. In the year 2005, what is the difference between the Education completion rate(%) of Other small states and Education completion rate(%) of Small states?
Offer a terse response. -10.93. In the year 2005, what is the difference between the Education completion rate(%) in Other small states and Education completion rate(%) in Madagascar?
Your answer should be very brief. 31.5. In the year 2005, what is the difference between the Education completion rate(%) of Other small states and Education completion rate(%) of Tanzania?
Your answer should be very brief. 41.22. In the year 2005, what is the difference between the Education completion rate(%) in Small states and Education completion rate(%) in Madagascar?
Your response must be concise. 42.43. In the year 2005, what is the difference between the Education completion rate(%) of Small states and Education completion rate(%) of Tanzania?
Offer a very short reply. 52.14. In the year 2005, what is the difference between the Education completion rate(%) of Madagascar and Education completion rate(%) of Tanzania?
Give a very brief answer. 9.71. In the year 2008, what is the difference between the Education completion rate(%) of Other small states and Education completion rate(%) of Small states?
Make the answer very short. -10.81. In the year 2008, what is the difference between the Education completion rate(%) in Other small states and Education completion rate(%) in Madagascar?
Offer a very short reply. 27.53. In the year 2008, what is the difference between the Education completion rate(%) of Other small states and Education completion rate(%) of Tanzania?
Offer a very short reply. 39.19. In the year 2008, what is the difference between the Education completion rate(%) in Small states and Education completion rate(%) in Madagascar?
Ensure brevity in your answer.  38.34. In the year 2008, what is the difference between the Education completion rate(%) of Small states and Education completion rate(%) of Tanzania?
Provide a succinct answer. 49.99. In the year 2008, what is the difference between the Education completion rate(%) of Madagascar and Education completion rate(%) of Tanzania?
Your answer should be very brief. 11.66. In the year 2009, what is the difference between the Education completion rate(%) in Other small states and Education completion rate(%) in Small states?
Provide a short and direct response. -9.98. In the year 2009, what is the difference between the Education completion rate(%) in Other small states and Education completion rate(%) in Madagascar?
Your answer should be very brief. 28.72. In the year 2009, what is the difference between the Education completion rate(%) of Other small states and Education completion rate(%) of Tanzania?
Keep it short and to the point. 35.39. In the year 2009, what is the difference between the Education completion rate(%) of Small states and Education completion rate(%) of Madagascar?
Ensure brevity in your answer.  38.7. In the year 2009, what is the difference between the Education completion rate(%) in Small states and Education completion rate(%) in Tanzania?
Your response must be concise. 45.37. In the year 2009, what is the difference between the Education completion rate(%) of Madagascar and Education completion rate(%) of Tanzania?
Offer a very short reply. 6.67. In the year 2012, what is the difference between the Education completion rate(%) in Other small states and Education completion rate(%) in Small states?
Keep it short and to the point. -7.91. In the year 2012, what is the difference between the Education completion rate(%) of Other small states and Education completion rate(%) of Madagascar?
Make the answer very short. 24.89. In the year 2012, what is the difference between the Education completion rate(%) of Other small states and Education completion rate(%) of Tanzania?
Provide a succinct answer. 21.45. In the year 2012, what is the difference between the Education completion rate(%) in Small states and Education completion rate(%) in Madagascar?
Ensure brevity in your answer.  32.81. In the year 2012, what is the difference between the Education completion rate(%) in Small states and Education completion rate(%) in Tanzania?
Provide a succinct answer. 29.36. In the year 2012, what is the difference between the Education completion rate(%) of Madagascar and Education completion rate(%) of Tanzania?
Offer a very short reply. -3.44. In the year 2013, what is the difference between the Education completion rate(%) of Other small states and Education completion rate(%) of Small states?
Offer a terse response. -7.49. In the year 2013, what is the difference between the Education completion rate(%) in Other small states and Education completion rate(%) in Madagascar?
Make the answer very short. 20.55. In the year 2013, what is the difference between the Education completion rate(%) of Other small states and Education completion rate(%) of Tanzania?
Offer a terse response. 24.3. In the year 2013, what is the difference between the Education completion rate(%) of Small states and Education completion rate(%) of Madagascar?
Your response must be concise. 28.03. In the year 2013, what is the difference between the Education completion rate(%) of Small states and Education completion rate(%) of Tanzania?
Your answer should be very brief. 31.78. In the year 2013, what is the difference between the Education completion rate(%) in Madagascar and Education completion rate(%) in Tanzania?
Make the answer very short. 3.75. What is the ratio of the Education completion rate(%) in Other small states in 2002 to that in 2003?
Give a very brief answer. 0.96. What is the ratio of the Education completion rate(%) of Small states in 2002 to that in 2003?
Offer a terse response. 0.97. What is the ratio of the Education completion rate(%) of Madagascar in 2002 to that in 2003?
Offer a very short reply. 0.93. What is the ratio of the Education completion rate(%) in Tanzania in 2002 to that in 2003?
Offer a very short reply. 0.88. What is the ratio of the Education completion rate(%) in Other small states in 2002 to that in 2004?
Offer a terse response. 0.93. What is the ratio of the Education completion rate(%) in Small states in 2002 to that in 2004?
Give a very brief answer. 0.95. What is the ratio of the Education completion rate(%) of Madagascar in 2002 to that in 2004?
Keep it short and to the point. 0.87. What is the ratio of the Education completion rate(%) in Tanzania in 2002 to that in 2004?
Ensure brevity in your answer.  0.87. What is the ratio of the Education completion rate(%) in Other small states in 2002 to that in 2005?
Make the answer very short. 0.9. What is the ratio of the Education completion rate(%) of Small states in 2002 to that in 2005?
Make the answer very short. 0.94. What is the ratio of the Education completion rate(%) of Madagascar in 2002 to that in 2005?
Provide a short and direct response. 0.73. What is the ratio of the Education completion rate(%) in Tanzania in 2002 to that in 2005?
Your response must be concise. 0.71. What is the ratio of the Education completion rate(%) in Other small states in 2002 to that in 2008?
Offer a terse response. 0.85. What is the ratio of the Education completion rate(%) in Small states in 2002 to that in 2008?
Keep it short and to the point. 0.9. What is the ratio of the Education completion rate(%) of Madagascar in 2002 to that in 2008?
Keep it short and to the point. 0.53. What is the ratio of the Education completion rate(%) in Tanzania in 2002 to that in 2008?
Your response must be concise. 0.45. What is the ratio of the Education completion rate(%) of Other small states in 2002 to that in 2009?
Provide a succinct answer. 0.8. What is the ratio of the Education completion rate(%) in Small states in 2002 to that in 2009?
Ensure brevity in your answer.  0.87. What is the ratio of the Education completion rate(%) of Madagascar in 2002 to that in 2009?
Ensure brevity in your answer.  0.49. What is the ratio of the Education completion rate(%) in Tanzania in 2002 to that in 2009?
Give a very brief answer. 0.28. What is the ratio of the Education completion rate(%) of Other small states in 2002 to that in 2012?
Your response must be concise. 0.77. What is the ratio of the Education completion rate(%) in Small states in 2002 to that in 2012?
Your response must be concise. 0.86. What is the ratio of the Education completion rate(%) of Madagascar in 2002 to that in 2012?
Provide a succinct answer. 0.4. What is the ratio of the Education completion rate(%) of Tanzania in 2002 to that in 2012?
Keep it short and to the point. 0.15. What is the ratio of the Education completion rate(%) of Other small states in 2002 to that in 2013?
Keep it short and to the point. 0.77. What is the ratio of the Education completion rate(%) in Small states in 2002 to that in 2013?
Offer a very short reply. 0.87. What is the ratio of the Education completion rate(%) of Madagascar in 2002 to that in 2013?
Provide a short and direct response. 0.35. What is the ratio of the Education completion rate(%) of Tanzania in 2002 to that in 2013?
Offer a very short reply. 0.17. What is the ratio of the Education completion rate(%) of Small states in 2003 to that in 2004?
Provide a succinct answer. 0.98. What is the ratio of the Education completion rate(%) of Madagascar in 2003 to that in 2004?
Ensure brevity in your answer.  0.94. What is the ratio of the Education completion rate(%) in Other small states in 2003 to that in 2005?
Offer a very short reply. 0.93. What is the ratio of the Education completion rate(%) in Small states in 2003 to that in 2005?
Offer a terse response. 0.96. What is the ratio of the Education completion rate(%) in Madagascar in 2003 to that in 2005?
Provide a succinct answer. 0.79. What is the ratio of the Education completion rate(%) in Tanzania in 2003 to that in 2005?
Give a very brief answer. 0.81. What is the ratio of the Education completion rate(%) in Other small states in 2003 to that in 2008?
Keep it short and to the point. 0.89. What is the ratio of the Education completion rate(%) in Small states in 2003 to that in 2008?
Offer a terse response. 0.93. What is the ratio of the Education completion rate(%) of Madagascar in 2003 to that in 2008?
Provide a short and direct response. 0.58. What is the ratio of the Education completion rate(%) in Tanzania in 2003 to that in 2008?
Make the answer very short. 0.51. What is the ratio of the Education completion rate(%) in Other small states in 2003 to that in 2009?
Your answer should be very brief. 0.83. What is the ratio of the Education completion rate(%) of Small states in 2003 to that in 2009?
Your response must be concise. 0.89. What is the ratio of the Education completion rate(%) in Madagascar in 2003 to that in 2009?
Offer a very short reply. 0.53. What is the ratio of the Education completion rate(%) of Tanzania in 2003 to that in 2009?
Offer a terse response. 0.32. What is the ratio of the Education completion rate(%) of Other small states in 2003 to that in 2012?
Offer a very short reply. 0.8. What is the ratio of the Education completion rate(%) in Small states in 2003 to that in 2012?
Give a very brief answer. 0.89. What is the ratio of the Education completion rate(%) in Madagascar in 2003 to that in 2012?
Offer a terse response. 0.43. What is the ratio of the Education completion rate(%) in Tanzania in 2003 to that in 2012?
Provide a short and direct response. 0.18. What is the ratio of the Education completion rate(%) in Other small states in 2003 to that in 2013?
Give a very brief answer. 0.8. What is the ratio of the Education completion rate(%) in Small states in 2003 to that in 2013?
Offer a very short reply. 0.89. What is the ratio of the Education completion rate(%) of Madagascar in 2003 to that in 2013?
Your response must be concise. 0.38. What is the ratio of the Education completion rate(%) in Tanzania in 2003 to that in 2013?
Provide a succinct answer. 0.19. What is the ratio of the Education completion rate(%) of Other small states in 2004 to that in 2005?
Provide a succinct answer. 0.97. What is the ratio of the Education completion rate(%) in Small states in 2004 to that in 2005?
Make the answer very short. 0.99. What is the ratio of the Education completion rate(%) in Madagascar in 2004 to that in 2005?
Your answer should be very brief. 0.84. What is the ratio of the Education completion rate(%) of Tanzania in 2004 to that in 2005?
Give a very brief answer. 0.81. What is the ratio of the Education completion rate(%) of Other small states in 2004 to that in 2008?
Keep it short and to the point. 0.92. What is the ratio of the Education completion rate(%) of Small states in 2004 to that in 2008?
Give a very brief answer. 0.95. What is the ratio of the Education completion rate(%) in Madagascar in 2004 to that in 2008?
Provide a succinct answer. 0.61. What is the ratio of the Education completion rate(%) in Tanzania in 2004 to that in 2008?
Give a very brief answer. 0.51. What is the ratio of the Education completion rate(%) in Other small states in 2004 to that in 2009?
Make the answer very short. 0.87. What is the ratio of the Education completion rate(%) of Small states in 2004 to that in 2009?
Your answer should be very brief. 0.91. What is the ratio of the Education completion rate(%) of Madagascar in 2004 to that in 2009?
Provide a succinct answer. 0.57. What is the ratio of the Education completion rate(%) in Tanzania in 2004 to that in 2009?
Your answer should be compact. 0.33. What is the ratio of the Education completion rate(%) of Other small states in 2004 to that in 2012?
Your answer should be compact. 0.83. What is the ratio of the Education completion rate(%) in Small states in 2004 to that in 2012?
Ensure brevity in your answer.  0.91. What is the ratio of the Education completion rate(%) of Madagascar in 2004 to that in 2012?
Give a very brief answer. 0.46. What is the ratio of the Education completion rate(%) in Tanzania in 2004 to that in 2012?
Your answer should be compact. 0.18. What is the ratio of the Education completion rate(%) of Other small states in 2004 to that in 2013?
Give a very brief answer. 0.83. What is the ratio of the Education completion rate(%) of Small states in 2004 to that in 2013?
Make the answer very short. 0.91. What is the ratio of the Education completion rate(%) in Madagascar in 2004 to that in 2013?
Offer a terse response. 0.4. What is the ratio of the Education completion rate(%) of Tanzania in 2004 to that in 2013?
Your response must be concise. 0.19. What is the ratio of the Education completion rate(%) in Other small states in 2005 to that in 2008?
Keep it short and to the point. 0.95. What is the ratio of the Education completion rate(%) of Small states in 2005 to that in 2008?
Make the answer very short. 0.96. What is the ratio of the Education completion rate(%) of Madagascar in 2005 to that in 2008?
Your answer should be very brief. 0.73. What is the ratio of the Education completion rate(%) of Tanzania in 2005 to that in 2008?
Offer a very short reply. 0.63. What is the ratio of the Education completion rate(%) in Other small states in 2005 to that in 2009?
Your answer should be compact. 0.89. What is the ratio of the Education completion rate(%) of Small states in 2005 to that in 2009?
Ensure brevity in your answer.  0.93. What is the ratio of the Education completion rate(%) of Madagascar in 2005 to that in 2009?
Keep it short and to the point. 0.67. What is the ratio of the Education completion rate(%) in Tanzania in 2005 to that in 2009?
Keep it short and to the point. 0.4. What is the ratio of the Education completion rate(%) in Other small states in 2005 to that in 2012?
Your answer should be compact. 0.85. What is the ratio of the Education completion rate(%) of Small states in 2005 to that in 2012?
Offer a very short reply. 0.92. What is the ratio of the Education completion rate(%) in Madagascar in 2005 to that in 2012?
Your response must be concise. 0.54. What is the ratio of the Education completion rate(%) in Tanzania in 2005 to that in 2012?
Keep it short and to the point. 0.22. What is the ratio of the Education completion rate(%) of Other small states in 2005 to that in 2013?
Your answer should be very brief. 0.85. What is the ratio of the Education completion rate(%) of Small states in 2005 to that in 2013?
Give a very brief answer. 0.92. What is the ratio of the Education completion rate(%) of Madagascar in 2005 to that in 2013?
Your response must be concise. 0.48. What is the ratio of the Education completion rate(%) of Tanzania in 2005 to that in 2013?
Make the answer very short. 0.24. What is the ratio of the Education completion rate(%) in Other small states in 2008 to that in 2009?
Offer a very short reply. 0.94. What is the ratio of the Education completion rate(%) in Small states in 2008 to that in 2009?
Offer a very short reply. 0.96. What is the ratio of the Education completion rate(%) in Madagascar in 2008 to that in 2009?
Your answer should be very brief. 0.92. What is the ratio of the Education completion rate(%) of Tanzania in 2008 to that in 2009?
Your answer should be compact. 0.64. What is the ratio of the Education completion rate(%) in Other small states in 2008 to that in 2012?
Make the answer very short. 0.9. What is the ratio of the Education completion rate(%) in Small states in 2008 to that in 2012?
Give a very brief answer. 0.96. What is the ratio of the Education completion rate(%) of Madagascar in 2008 to that in 2012?
Ensure brevity in your answer.  0.74. What is the ratio of the Education completion rate(%) in Tanzania in 2008 to that in 2012?
Provide a short and direct response. 0.35. What is the ratio of the Education completion rate(%) of Other small states in 2008 to that in 2013?
Your answer should be very brief. 0.9. What is the ratio of the Education completion rate(%) of Small states in 2008 to that in 2013?
Keep it short and to the point. 0.96. What is the ratio of the Education completion rate(%) of Madagascar in 2008 to that in 2013?
Make the answer very short. 0.65. What is the ratio of the Education completion rate(%) in Tanzania in 2008 to that in 2013?
Keep it short and to the point. 0.38. What is the ratio of the Education completion rate(%) of Other small states in 2009 to that in 2012?
Keep it short and to the point. 0.96. What is the ratio of the Education completion rate(%) in Madagascar in 2009 to that in 2012?
Your answer should be very brief. 0.8. What is the ratio of the Education completion rate(%) of Tanzania in 2009 to that in 2012?
Offer a terse response. 0.54. What is the ratio of the Education completion rate(%) in Other small states in 2009 to that in 2013?
Ensure brevity in your answer.  0.96. What is the ratio of the Education completion rate(%) of Madagascar in 2009 to that in 2013?
Your answer should be compact. 0.71. What is the ratio of the Education completion rate(%) of Tanzania in 2009 to that in 2013?
Your answer should be compact. 0.59. What is the ratio of the Education completion rate(%) in Small states in 2012 to that in 2013?
Offer a very short reply. 1.01. What is the ratio of the Education completion rate(%) of Madagascar in 2012 to that in 2013?
Offer a very short reply. 0.88. What is the ratio of the Education completion rate(%) of Tanzania in 2012 to that in 2013?
Your answer should be compact. 1.09. What is the difference between the highest and the second highest Education completion rate(%) in Other small states?
Your answer should be very brief. 0.02. What is the difference between the highest and the second highest Education completion rate(%) in Small states?
Ensure brevity in your answer.  0.4. What is the difference between the highest and the second highest Education completion rate(%) of Madagascar?
Provide a succinct answer. 4.37. What is the difference between the highest and the second highest Education completion rate(%) in Tanzania?
Provide a succinct answer. 2.83. What is the difference between the highest and the lowest Education completion rate(%) of Other small states?
Provide a succinct answer. 13.46. What is the difference between the highest and the lowest Education completion rate(%) in Small states?
Your answer should be compact. 9.04. What is the difference between the highest and the lowest Education completion rate(%) of Madagascar?
Provide a succinct answer. 23.98. What is the difference between the highest and the lowest Education completion rate(%) of Tanzania?
Offer a very short reply. 30.38. 